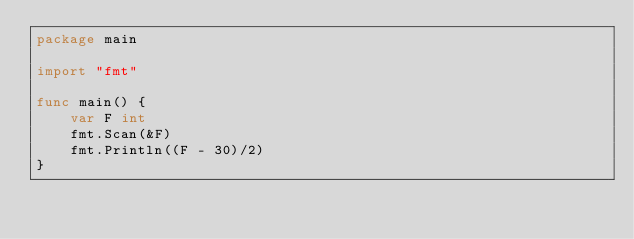<code> <loc_0><loc_0><loc_500><loc_500><_Go_>package main

import "fmt"

func main() {
	var F int
	fmt.Scan(&F)
	fmt.Println((F - 30)/2)
}
</code> 